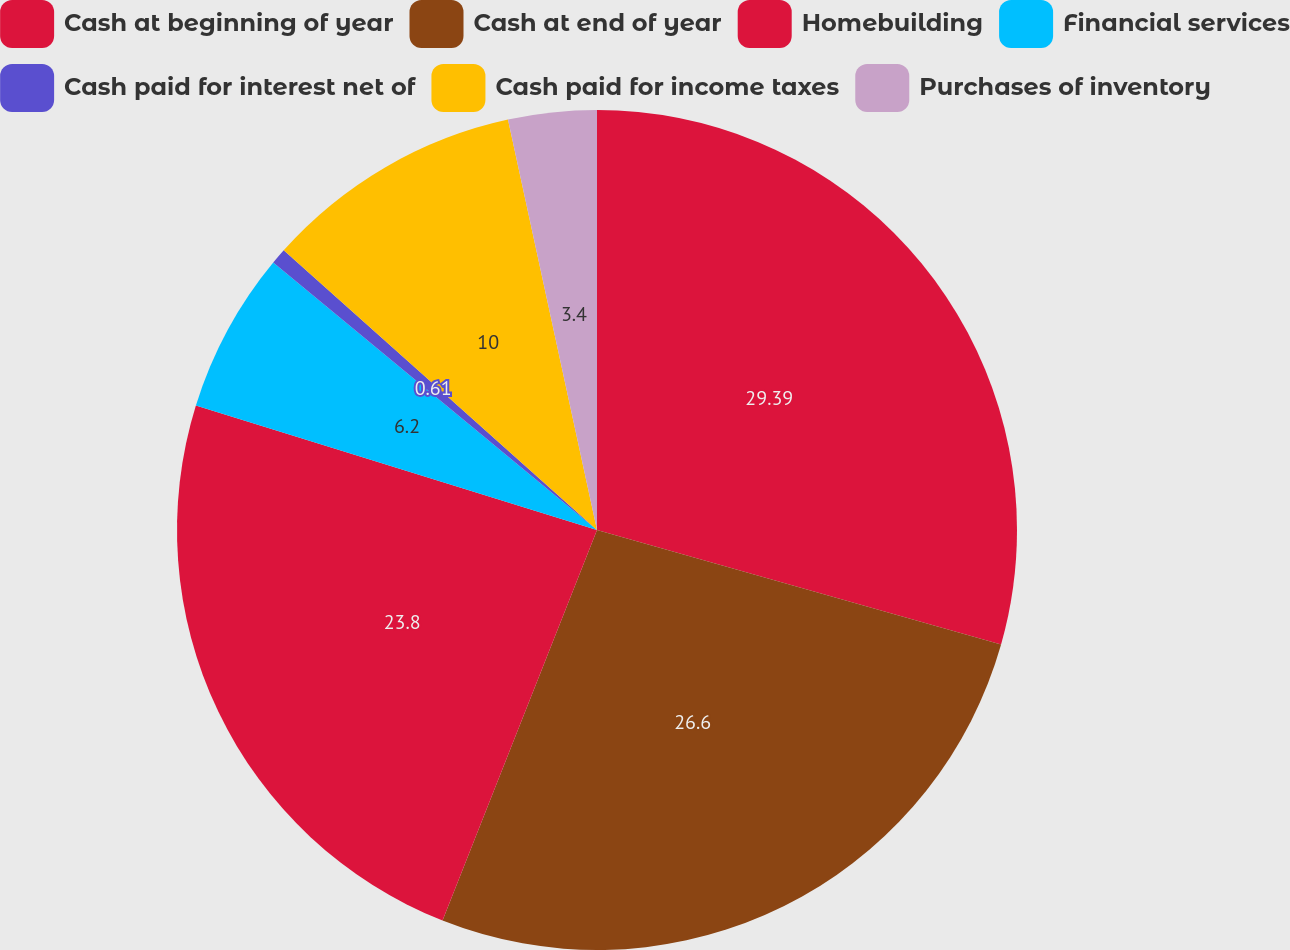Convert chart to OTSL. <chart><loc_0><loc_0><loc_500><loc_500><pie_chart><fcel>Cash at beginning of year<fcel>Cash at end of year<fcel>Homebuilding<fcel>Financial services<fcel>Cash paid for interest net of<fcel>Cash paid for income taxes<fcel>Purchases of inventory<nl><fcel>29.4%<fcel>26.6%<fcel>23.8%<fcel>6.2%<fcel>0.61%<fcel>10.0%<fcel>3.4%<nl></chart> 